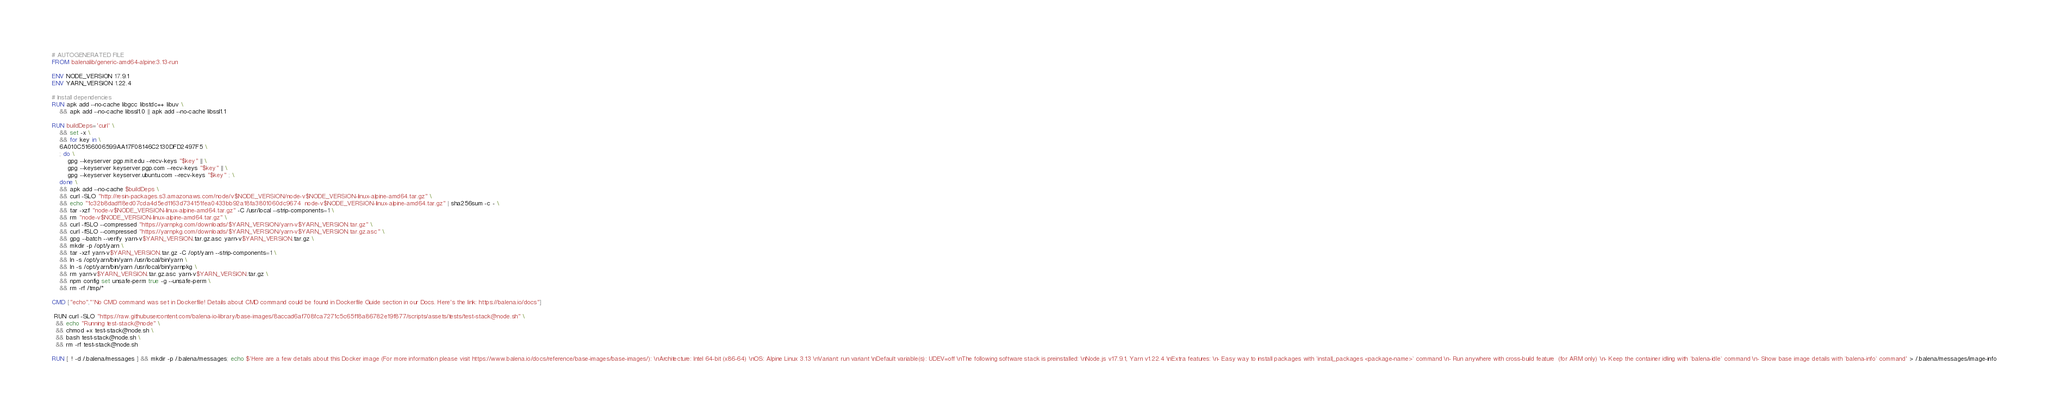Convert code to text. <code><loc_0><loc_0><loc_500><loc_500><_Dockerfile_># AUTOGENERATED FILE
FROM balenalib/generic-amd64-alpine:3.13-run

ENV NODE_VERSION 17.9.1
ENV YARN_VERSION 1.22.4

# Install dependencies
RUN apk add --no-cache libgcc libstdc++ libuv \
	&& apk add --no-cache libssl1.0 || apk add --no-cache libssl1.1

RUN buildDeps='curl' \
	&& set -x \
	&& for key in \
	6A010C5166006599AA17F08146C2130DFD2497F5 \
	; do \
		gpg --keyserver pgp.mit.edu --recv-keys "$key" || \
		gpg --keyserver keyserver.pgp.com --recv-keys "$key" || \
		gpg --keyserver keyserver.ubuntu.com --recv-keys "$key" ; \
	done \
	&& apk add --no-cache $buildDeps \
	&& curl -SLO "http://resin-packages.s3.amazonaws.com/node/v$NODE_VERSION/node-v$NODE_VERSION-linux-alpine-amd64.tar.gz" \
	&& echo "1c32b8dadf18ed07cda4d5ed1163d734151fea0433bb92a18fa3801060dc9674  node-v$NODE_VERSION-linux-alpine-amd64.tar.gz" | sha256sum -c - \
	&& tar -xzf "node-v$NODE_VERSION-linux-alpine-amd64.tar.gz" -C /usr/local --strip-components=1 \
	&& rm "node-v$NODE_VERSION-linux-alpine-amd64.tar.gz" \
	&& curl -fSLO --compressed "https://yarnpkg.com/downloads/$YARN_VERSION/yarn-v$YARN_VERSION.tar.gz" \
	&& curl -fSLO --compressed "https://yarnpkg.com/downloads/$YARN_VERSION/yarn-v$YARN_VERSION.tar.gz.asc" \
	&& gpg --batch --verify yarn-v$YARN_VERSION.tar.gz.asc yarn-v$YARN_VERSION.tar.gz \
	&& mkdir -p /opt/yarn \
	&& tar -xzf yarn-v$YARN_VERSION.tar.gz -C /opt/yarn --strip-components=1 \
	&& ln -s /opt/yarn/bin/yarn /usr/local/bin/yarn \
	&& ln -s /opt/yarn/bin/yarn /usr/local/bin/yarnpkg \
	&& rm yarn-v$YARN_VERSION.tar.gz.asc yarn-v$YARN_VERSION.tar.gz \
	&& npm config set unsafe-perm true -g --unsafe-perm \
	&& rm -rf /tmp/*

CMD ["echo","'No CMD command was set in Dockerfile! Details about CMD command could be found in Dockerfile Guide section in our Docs. Here's the link: https://balena.io/docs"]

 RUN curl -SLO "https://raw.githubusercontent.com/balena-io-library/base-images/8accad6af708fca7271c5c65f18a86782e19f877/scripts/assets/tests/test-stack@node.sh" \
  && echo "Running test-stack@node" \
  && chmod +x test-stack@node.sh \
  && bash test-stack@node.sh \
  && rm -rf test-stack@node.sh 

RUN [ ! -d /.balena/messages ] && mkdir -p /.balena/messages; echo $'Here are a few details about this Docker image (For more information please visit https://www.balena.io/docs/reference/base-images/base-images/): \nArchitecture: Intel 64-bit (x86-64) \nOS: Alpine Linux 3.13 \nVariant: run variant \nDefault variable(s): UDEV=off \nThe following software stack is preinstalled: \nNode.js v17.9.1, Yarn v1.22.4 \nExtra features: \n- Easy way to install packages with `install_packages <package-name>` command \n- Run anywhere with cross-build feature  (for ARM only) \n- Keep the container idling with `balena-idle` command \n- Show base image details with `balena-info` command' > /.balena/messages/image-info</code> 